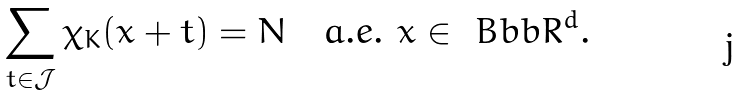Convert formula to latex. <formula><loc_0><loc_0><loc_500><loc_500>\sum _ { t \in { \mathcal { J } } } \chi _ { K } ( x + t ) = N \quad a . e . \ x \in \ B b b R ^ { d } .</formula> 